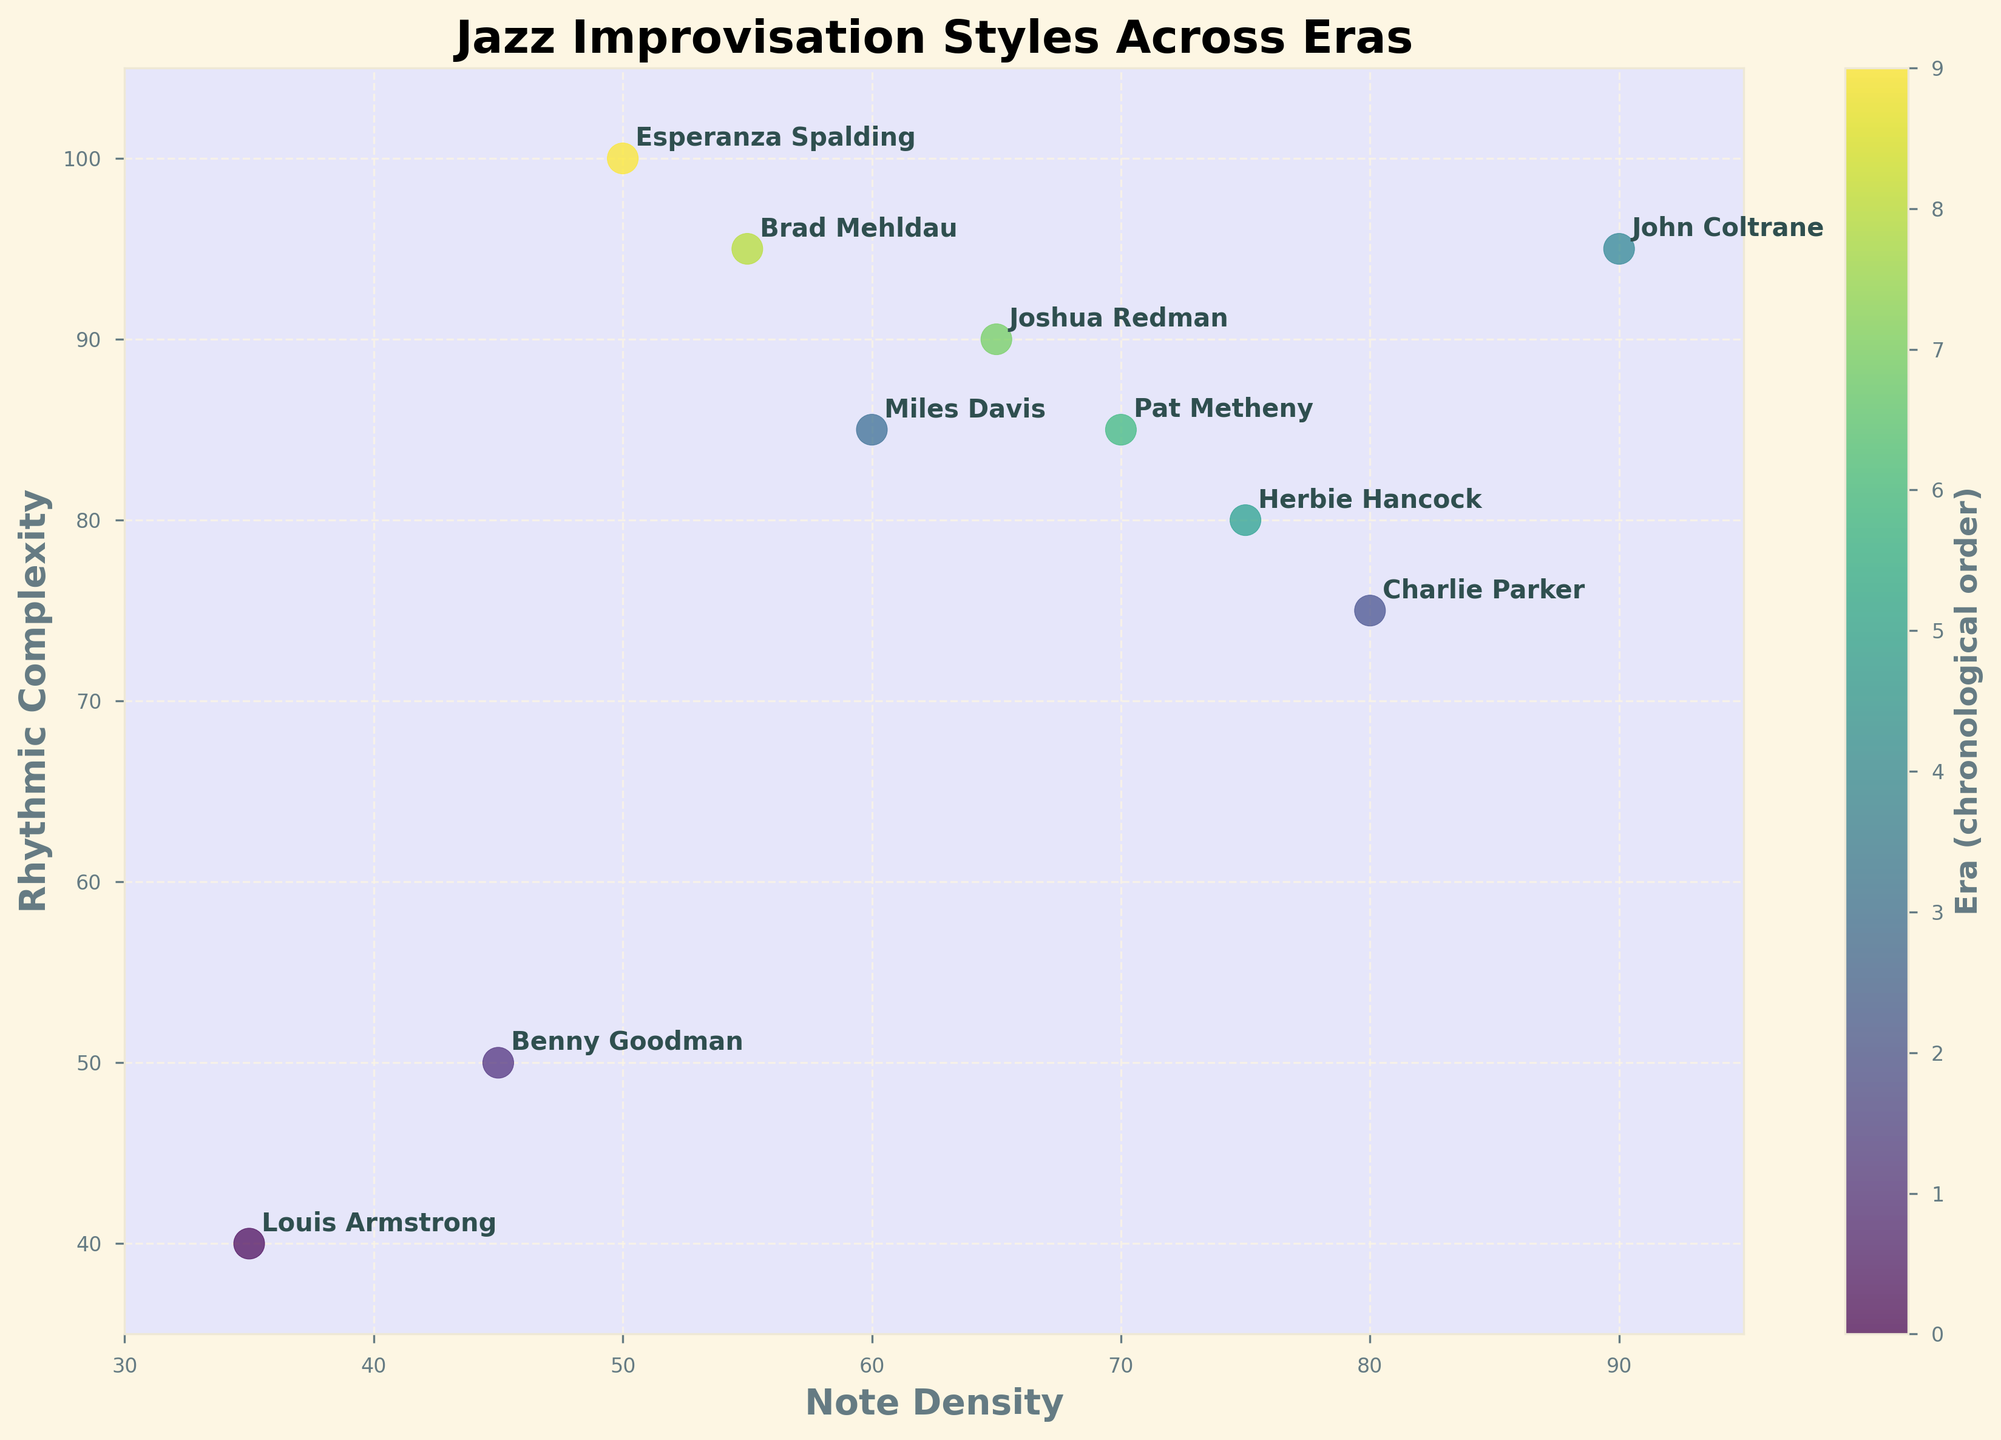What is the title of the figure? The title of the figure is written at the top of the plot.
Answer: Jazz Improvisation Styles Across Eras Which artist has the highest rhythmic complexity? To find the artist with the highest rhythmic complexity, locate the data point with the highest value on the y-axis (Rhythmic Complexity).
Answer: Esperanza Spalding What is the note density of Benny Goodman? Locate Benny Goodman's position on the plot and refer to the x-axis value (Note Density).
Answer: 45 How many artists have both note density and rhythmic complexity greater than 80? Check the scatter points to find artists whose positions are above 80 on both axes.
Answer: Two artists (John Coltrane, Herbie Hancock) Who has a higher rhythmic complexity, Charlie Parker or Pat Metheny? Compare the y-axis values of the points labeled Charlie Parker and Pat Metheny.
Answer: Pat Metheny What is the difference in rhythmic complexity between John Coltrane and Joshua Redman? Subtract the y-axis value of Joshua Redman from John Coltrane.
Answer: 5 (95 - 90) Which era has the densest notes? Look for the highest x-axis value (Note Density) and check the corresponding era.
Answer: 1960s (John Coltrane) What is the average note density for the artists from the 1990s to 2010s? Add the note densities of the artists from the 1990s to 2010s and divide by the number of artists (3 in total).
Answer: (65 + 55 + 50) / 3 = 56.67 Which artist has the closest note density to Miles Davis? Check the x-axis value of Miles Davis and compare it with others to find the closest one.
Answer: Brad Mehldau (55 vs. Miles Davis's 60) How many artists have a note density between 50 and 70? Count the data points where the x-axis values (Note Density) fall within the 50 to 70 range.
Answer: Four artists (Brad Mehldau, Pat Metheny, Joshua Redman, Esperanza Spalding) 